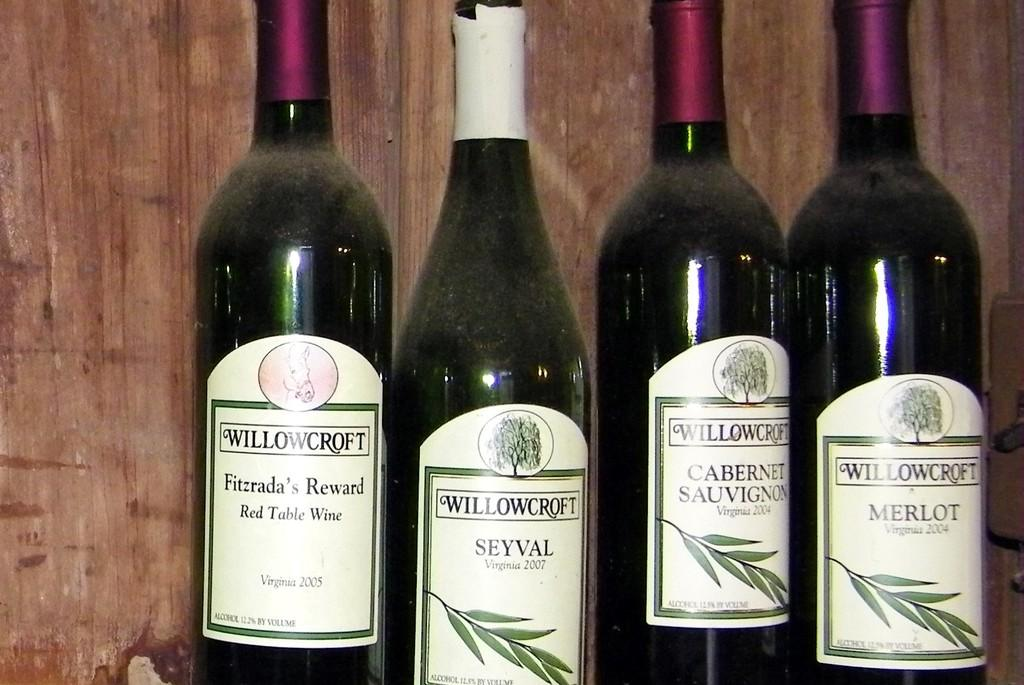<image>
Present a compact description of the photo's key features. The four bottles of wine are from the company Willowcroft 